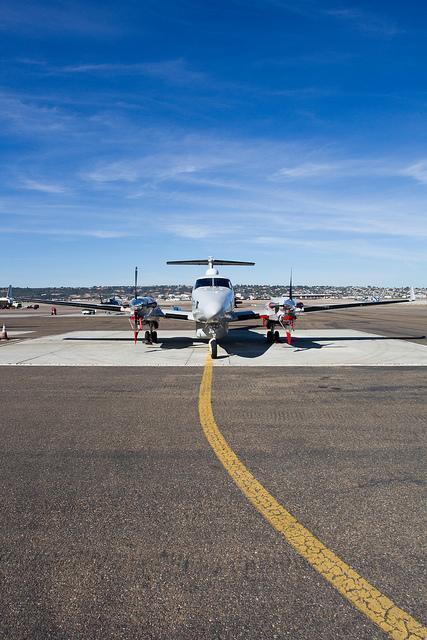How many engines on the plane?
Give a very brief answer. 2. 